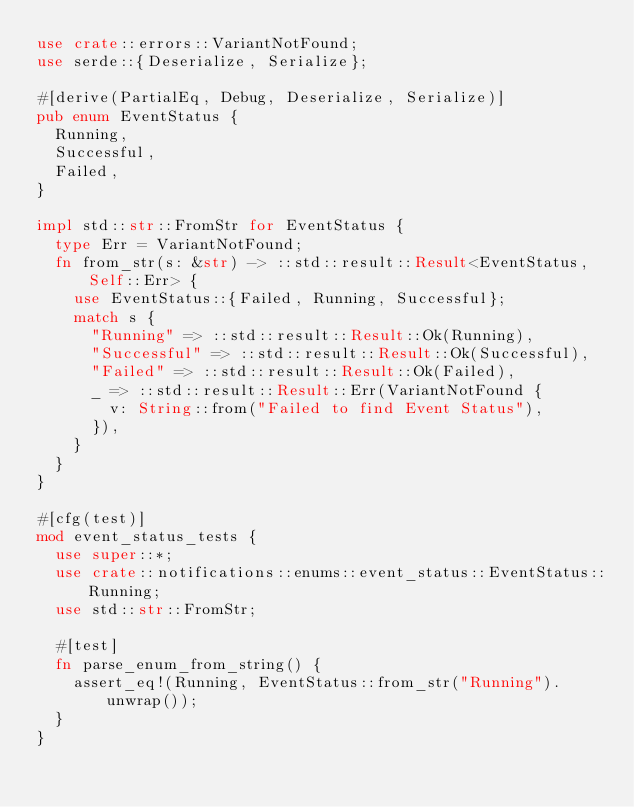Convert code to text. <code><loc_0><loc_0><loc_500><loc_500><_Rust_>use crate::errors::VariantNotFound;
use serde::{Deserialize, Serialize};

#[derive(PartialEq, Debug, Deserialize, Serialize)]
pub enum EventStatus {
  Running,
  Successful,
  Failed,
}

impl std::str::FromStr for EventStatus {
  type Err = VariantNotFound;
  fn from_str(s: &str) -> ::std::result::Result<EventStatus, Self::Err> {
    use EventStatus::{Failed, Running, Successful};
    match s {
      "Running" => ::std::result::Result::Ok(Running),
      "Successful" => ::std::result::Result::Ok(Successful),
      "Failed" => ::std::result::Result::Ok(Failed),
      _ => ::std::result::Result::Err(VariantNotFound {
        v: String::from("Failed to find Event Status"),
      }),
    }
  }
}

#[cfg(test)]
mod event_status_tests {
  use super::*;
  use crate::notifications::enums::event_status::EventStatus::Running;
  use std::str::FromStr;

  #[test]
  fn parse_enum_from_string() {
    assert_eq!(Running, EventStatus::from_str("Running").unwrap());
  }
}
</code> 